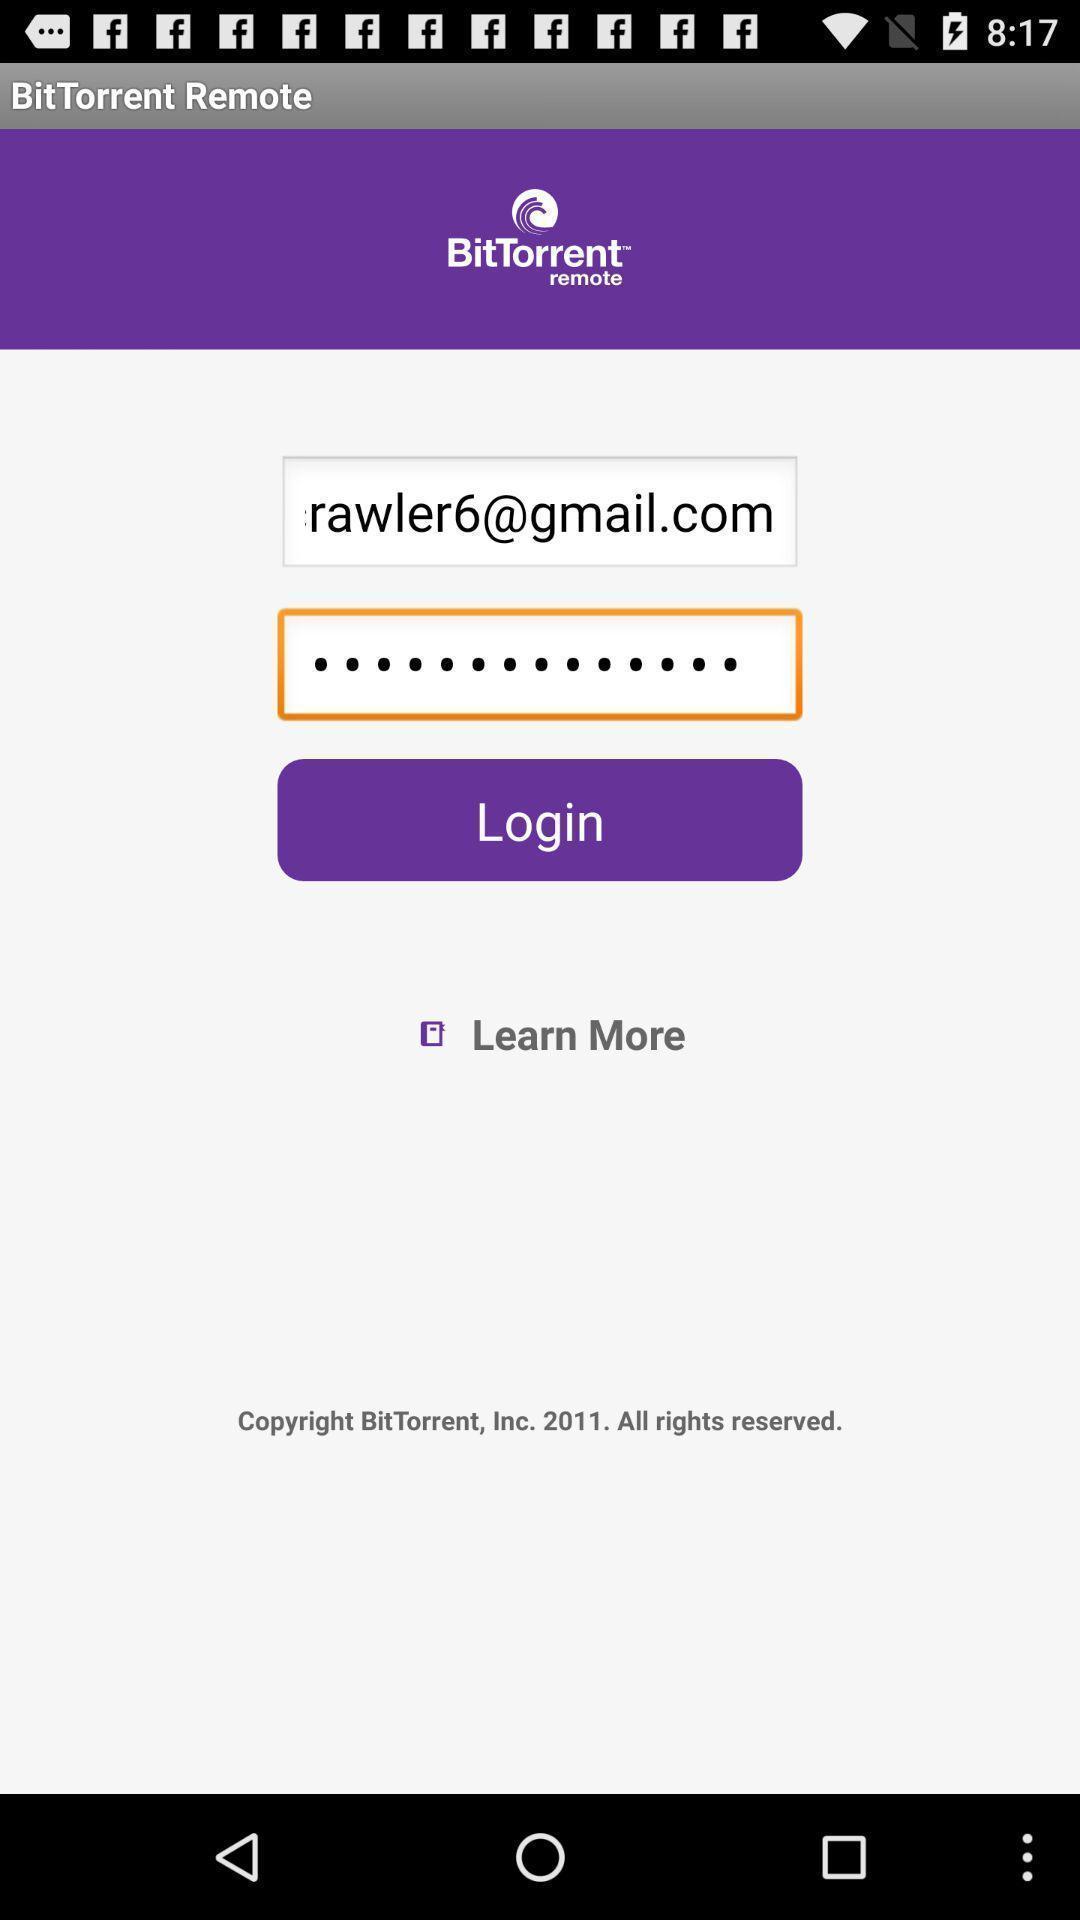What is the overall content of this screenshot? Welcome to the login page. 